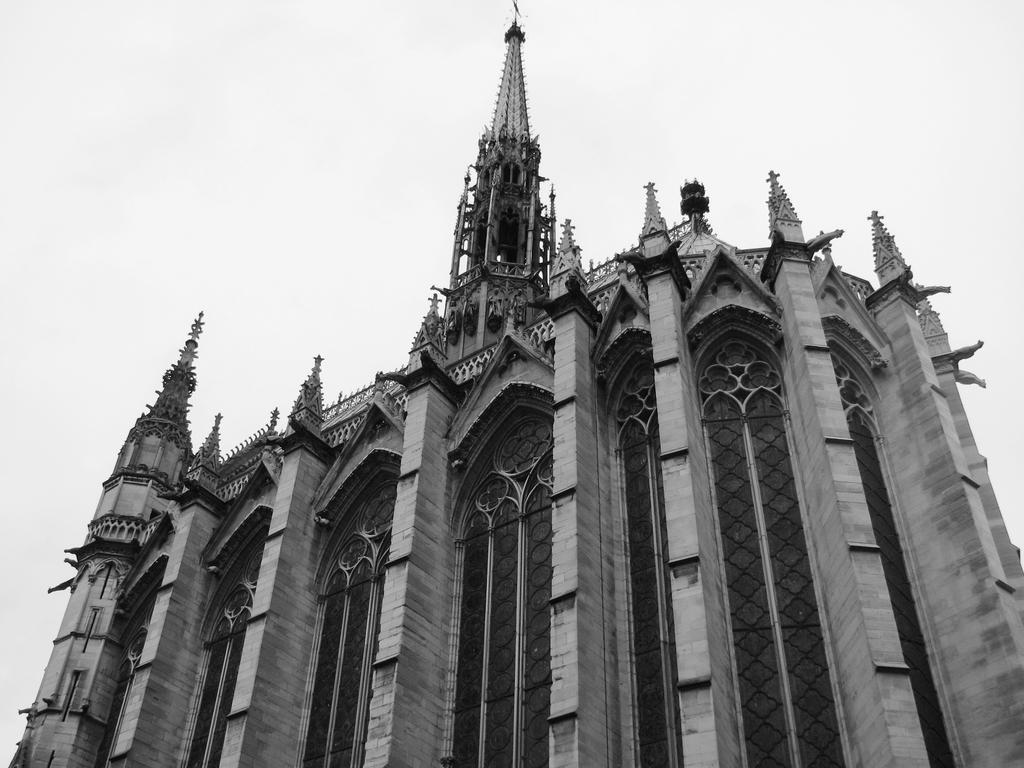What is the main structure in the center of the image? There is a building in the center of the image. What can be seen at the top of the image? The sky is visible at the top of the image. What feature is present in the center of the image? There are railings in the center of the image. What type of tub is visible in the image? There is no tub present in the image. Can you tell me the specific details of the lead in the image? There is no mention of lead in the provided facts, and therefore no such details can be discussed. 